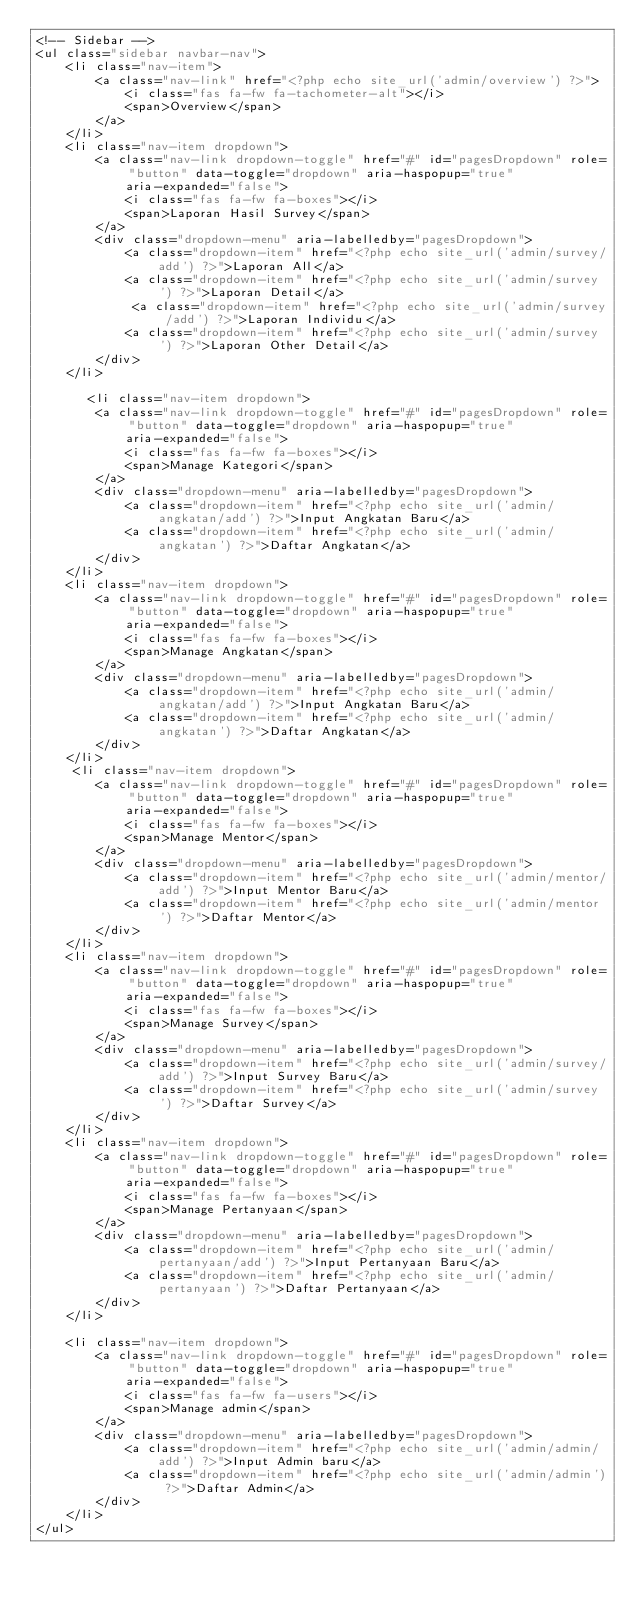Convert code to text. <code><loc_0><loc_0><loc_500><loc_500><_PHP_><!-- Sidebar -->
<ul class="sidebar navbar-nav">
    <li class="nav-item">
        <a class="nav-link" href="<?php echo site_url('admin/overview') ?>">
            <i class="fas fa-fw fa-tachometer-alt"></i>
            <span>Overview</span>
        </a>
    </li>
    <li class="nav-item dropdown">
        <a class="nav-link dropdown-toggle" href="#" id="pagesDropdown" role="button" data-toggle="dropdown" aria-haspopup="true"
            aria-expanded="false">
            <i class="fas fa-fw fa-boxes"></i>
            <span>Laporan Hasil Survey</span>
        </a>
        <div class="dropdown-menu" aria-labelledby="pagesDropdown">
            <a class="dropdown-item" href="<?php echo site_url('admin/survey/add') ?>">Laporan All</a>
            <a class="dropdown-item" href="<?php echo site_url('admin/survey') ?>">Laporan Detail</a>
             <a class="dropdown-item" href="<?php echo site_url('admin/survey/add') ?>">Laporan Individu</a>
            <a class="dropdown-item" href="<?php echo site_url('admin/survey') ?>">Laporan Other Detail</a>
        </div>
    </li>
    
       <li class="nav-item dropdown">
        <a class="nav-link dropdown-toggle" href="#" id="pagesDropdown" role="button" data-toggle="dropdown" aria-haspopup="true"
            aria-expanded="false">
            <i class="fas fa-fw fa-boxes"></i>
            <span>Manage Kategori</span>
        </a>
        <div class="dropdown-menu" aria-labelledby="pagesDropdown">
            <a class="dropdown-item" href="<?php echo site_url('admin/angkatan/add') ?>">Input Angkatan Baru</a>
            <a class="dropdown-item" href="<?php echo site_url('admin/angkatan') ?>">Daftar Angkatan</a>
        </div>
    </li>
    <li class="nav-item dropdown">
        <a class="nav-link dropdown-toggle" href="#" id="pagesDropdown" role="button" data-toggle="dropdown" aria-haspopup="true"
            aria-expanded="false">
            <i class="fas fa-fw fa-boxes"></i>
            <span>Manage Angkatan</span>
        </a>
        <div class="dropdown-menu" aria-labelledby="pagesDropdown">
            <a class="dropdown-item" href="<?php echo site_url('admin/angkatan/add') ?>">Input Angkatan Baru</a>
            <a class="dropdown-item" href="<?php echo site_url('admin/angkatan') ?>">Daftar Angkatan</a>
        </div>
    </li>
     <li class="nav-item dropdown">
        <a class="nav-link dropdown-toggle" href="#" id="pagesDropdown" role="button" data-toggle="dropdown" aria-haspopup="true"
            aria-expanded="false">
            <i class="fas fa-fw fa-boxes"></i>
            <span>Manage Mentor</span>
        </a>
        <div class="dropdown-menu" aria-labelledby="pagesDropdown">
            <a class="dropdown-item" href="<?php echo site_url('admin/mentor/add') ?>">Input Mentor Baru</a>
            <a class="dropdown-item" href="<?php echo site_url('admin/mentor') ?>">Daftar Mentor</a>
        </div>
    </li>
    <li class="nav-item dropdown">
        <a class="nav-link dropdown-toggle" href="#" id="pagesDropdown" role="button" data-toggle="dropdown" aria-haspopup="true"
            aria-expanded="false">
            <i class="fas fa-fw fa-boxes"></i>
            <span>Manage Survey</span>
        </a>
        <div class="dropdown-menu" aria-labelledby="pagesDropdown">
            <a class="dropdown-item" href="<?php echo site_url('admin/survey/add') ?>">Input Survey Baru</a>
            <a class="dropdown-item" href="<?php echo site_url('admin/survey') ?>">Daftar Survey</a>
        </div>
    </li>
    <li class="nav-item dropdown">
        <a class="nav-link dropdown-toggle" href="#" id="pagesDropdown" role="button" data-toggle="dropdown" aria-haspopup="true"
            aria-expanded="false">
            <i class="fas fa-fw fa-boxes"></i>
            <span>Manage Pertanyaan</span>
        </a>
        <div class="dropdown-menu" aria-labelledby="pagesDropdown">
            <a class="dropdown-item" href="<?php echo site_url('admin/pertanyaan/add') ?>">Input Pertanyaan Baru</a>
            <a class="dropdown-item" href="<?php echo site_url('admin/pertanyaan') ?>">Daftar Pertanyaan</a>
        </div>
    </li>
  
    <li class="nav-item dropdown">
        <a class="nav-link dropdown-toggle" href="#" id="pagesDropdown" role="button" data-toggle="dropdown" aria-haspopup="true"
            aria-expanded="false">
            <i class="fas fa-fw fa-users"></i>
            <span>Manage admin</span>
        </a>
        <div class="dropdown-menu" aria-labelledby="pagesDropdown">
            <a class="dropdown-item" href="<?php echo site_url('admin/admin/add') ?>">Input Admin baru</a>
            <a class="dropdown-item" href="<?php echo site_url('admin/admin') ?>">Daftar Admin</a>
        </div>
    </li>
</ul></code> 